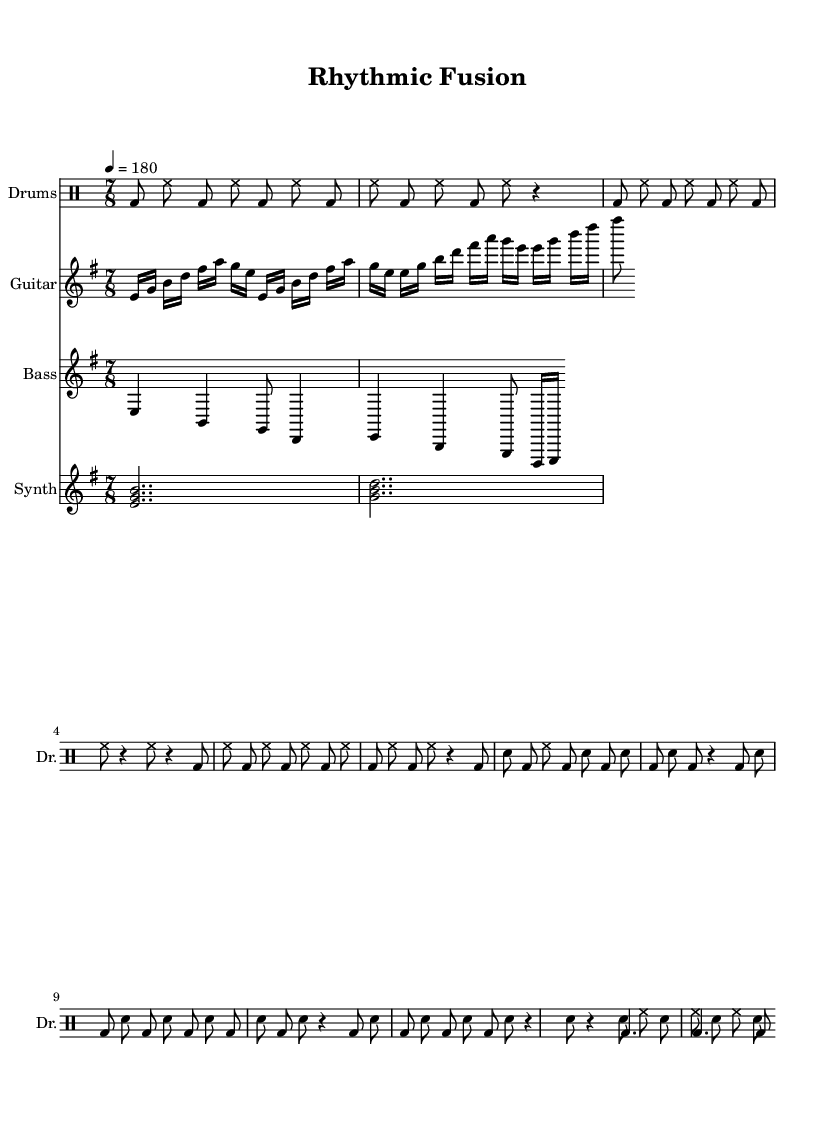What is the key signature of this music? The key signature is E minor, as indicated by the one sharp (F#).
Answer: E minor What is the time signature of the piece? The time signature is 7/8, as shown in the initial part of the score.
Answer: 7/8 What is the tempo marking given in the score? The tempo marking states "4 = 180," which indicates the number of beats per minute for the quarter note.
Answer: 180 How many measures are in the chorus section? The chorus section consists of four measures, as indicated by the repeating pattern and layout.
Answer: 4 What kind of polyrhythm is used in the bridge section? The bridge section uses a 3:2 polyrhythm, demonstrated through the separate rhythmic lines that interact with each other.
Answer: 3:2 Which instruments are featured in this composition? The composition features drums, guitar, bass, and synth, as listed in the score layout.
Answer: Drums, guitar, bass, synth What rhythmic pattern is repeated in the verse section? The verse section repeats a rhythmic pattern dominated by bass drum and hi-hat interplays, showcasing a consistent groove.
Answer: Bass drum and hi-hat 